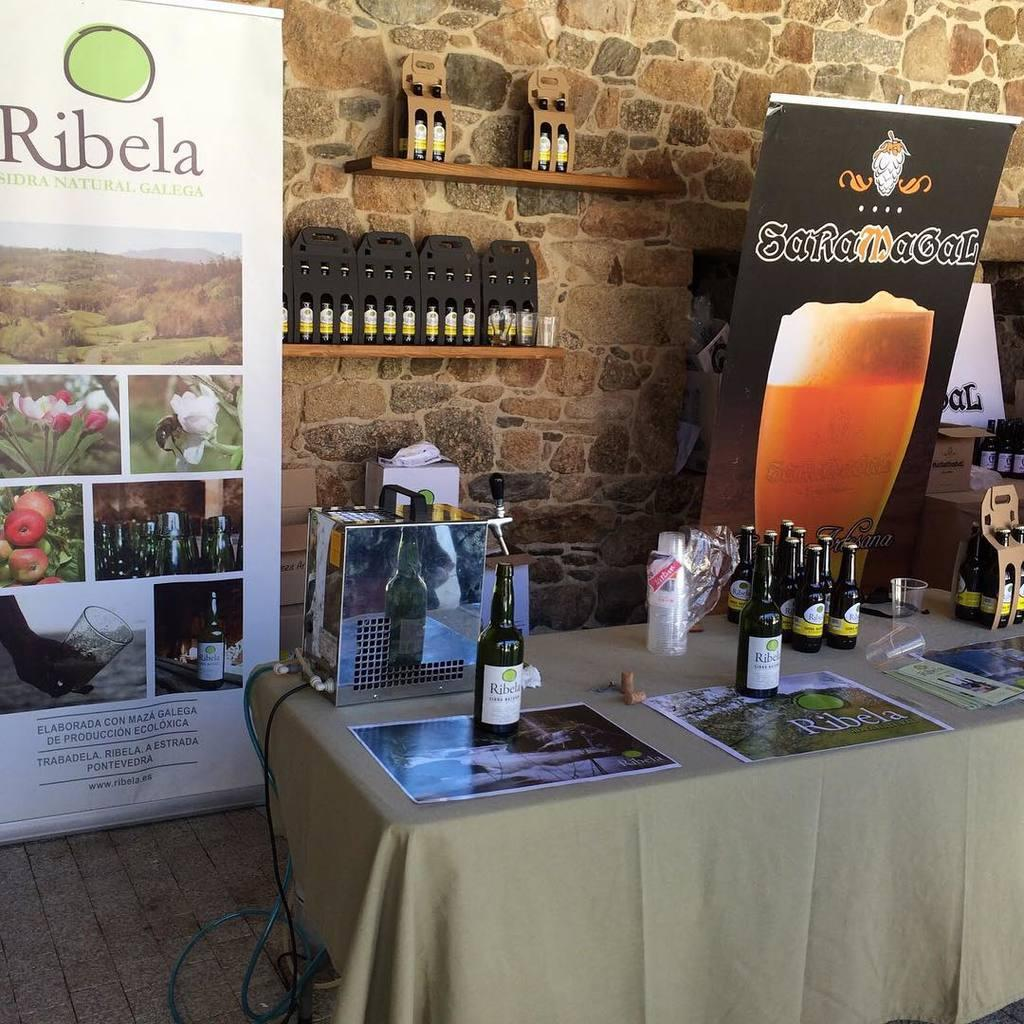What type of furniture is present in the image? There is a table in the image. What objects are placed on the table? There are glasses on the table. What can be seen on the wall in the image? There is a banner on the wall. What type of pump is visible on the table in the image? There is no pump present on the table in the image. 